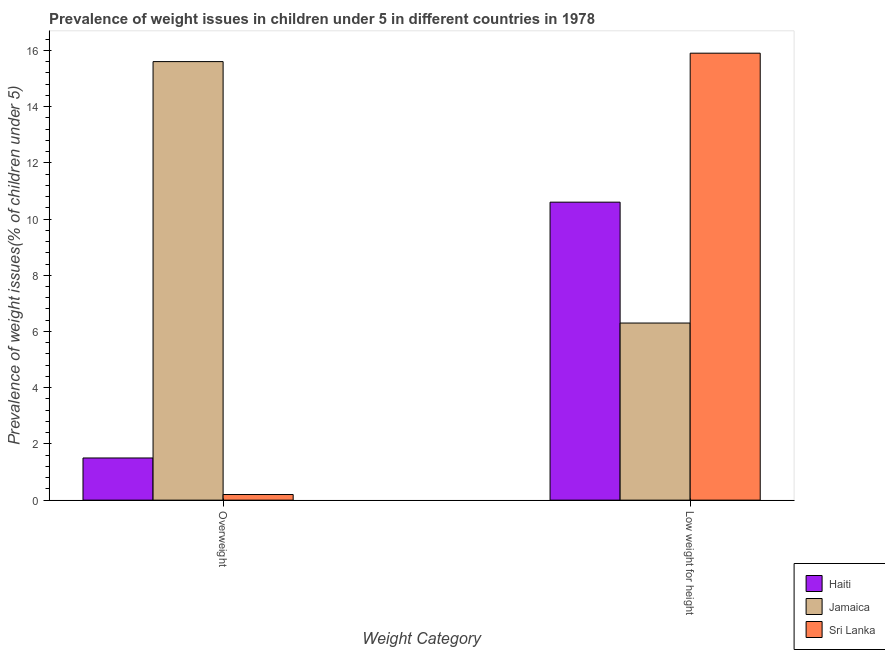Are the number of bars per tick equal to the number of legend labels?
Make the answer very short. Yes. How many bars are there on the 1st tick from the left?
Offer a terse response. 3. What is the label of the 1st group of bars from the left?
Give a very brief answer. Overweight. What is the percentage of underweight children in Haiti?
Provide a short and direct response. 10.6. Across all countries, what is the maximum percentage of overweight children?
Your response must be concise. 15.6. Across all countries, what is the minimum percentage of underweight children?
Your response must be concise. 6.3. In which country was the percentage of underweight children maximum?
Your answer should be very brief. Sri Lanka. In which country was the percentage of overweight children minimum?
Make the answer very short. Sri Lanka. What is the total percentage of underweight children in the graph?
Your response must be concise. 32.8. What is the difference between the percentage of overweight children in Sri Lanka and that in Jamaica?
Your answer should be compact. -15.4. What is the difference between the percentage of overweight children in Jamaica and the percentage of underweight children in Haiti?
Give a very brief answer. 5. What is the average percentage of overweight children per country?
Keep it short and to the point. 5.77. What is the difference between the percentage of underweight children and percentage of overweight children in Jamaica?
Give a very brief answer. -9.3. What is the ratio of the percentage of underweight children in Sri Lanka to that in Jamaica?
Your answer should be very brief. 2.52. What does the 2nd bar from the left in Overweight represents?
Offer a terse response. Jamaica. What does the 1st bar from the right in Low weight for height represents?
Offer a very short reply. Sri Lanka. Are all the bars in the graph horizontal?
Your answer should be compact. No. How many countries are there in the graph?
Keep it short and to the point. 3. What is the difference between two consecutive major ticks on the Y-axis?
Make the answer very short. 2. Are the values on the major ticks of Y-axis written in scientific E-notation?
Make the answer very short. No. Does the graph contain any zero values?
Provide a short and direct response. No. What is the title of the graph?
Offer a terse response. Prevalence of weight issues in children under 5 in different countries in 1978. What is the label or title of the X-axis?
Your answer should be compact. Weight Category. What is the label or title of the Y-axis?
Keep it short and to the point. Prevalence of weight issues(% of children under 5). What is the Prevalence of weight issues(% of children under 5) in Haiti in Overweight?
Your response must be concise. 1.5. What is the Prevalence of weight issues(% of children under 5) in Jamaica in Overweight?
Give a very brief answer. 15.6. What is the Prevalence of weight issues(% of children under 5) in Sri Lanka in Overweight?
Provide a succinct answer. 0.2. What is the Prevalence of weight issues(% of children under 5) in Haiti in Low weight for height?
Provide a succinct answer. 10.6. What is the Prevalence of weight issues(% of children under 5) of Jamaica in Low weight for height?
Ensure brevity in your answer.  6.3. What is the Prevalence of weight issues(% of children under 5) in Sri Lanka in Low weight for height?
Your answer should be very brief. 15.9. Across all Weight Category, what is the maximum Prevalence of weight issues(% of children under 5) in Haiti?
Provide a succinct answer. 10.6. Across all Weight Category, what is the maximum Prevalence of weight issues(% of children under 5) of Jamaica?
Offer a very short reply. 15.6. Across all Weight Category, what is the maximum Prevalence of weight issues(% of children under 5) in Sri Lanka?
Offer a very short reply. 15.9. Across all Weight Category, what is the minimum Prevalence of weight issues(% of children under 5) in Haiti?
Offer a very short reply. 1.5. Across all Weight Category, what is the minimum Prevalence of weight issues(% of children under 5) of Jamaica?
Offer a very short reply. 6.3. Across all Weight Category, what is the minimum Prevalence of weight issues(% of children under 5) of Sri Lanka?
Provide a succinct answer. 0.2. What is the total Prevalence of weight issues(% of children under 5) of Haiti in the graph?
Your response must be concise. 12.1. What is the total Prevalence of weight issues(% of children under 5) in Jamaica in the graph?
Make the answer very short. 21.9. What is the difference between the Prevalence of weight issues(% of children under 5) in Sri Lanka in Overweight and that in Low weight for height?
Provide a short and direct response. -15.7. What is the difference between the Prevalence of weight issues(% of children under 5) of Haiti in Overweight and the Prevalence of weight issues(% of children under 5) of Sri Lanka in Low weight for height?
Make the answer very short. -14.4. What is the difference between the Prevalence of weight issues(% of children under 5) of Jamaica in Overweight and the Prevalence of weight issues(% of children under 5) of Sri Lanka in Low weight for height?
Make the answer very short. -0.3. What is the average Prevalence of weight issues(% of children under 5) of Haiti per Weight Category?
Offer a terse response. 6.05. What is the average Prevalence of weight issues(% of children under 5) in Jamaica per Weight Category?
Make the answer very short. 10.95. What is the average Prevalence of weight issues(% of children under 5) of Sri Lanka per Weight Category?
Your answer should be very brief. 8.05. What is the difference between the Prevalence of weight issues(% of children under 5) of Haiti and Prevalence of weight issues(% of children under 5) of Jamaica in Overweight?
Make the answer very short. -14.1. What is the difference between the Prevalence of weight issues(% of children under 5) of Haiti and Prevalence of weight issues(% of children under 5) of Jamaica in Low weight for height?
Keep it short and to the point. 4.3. What is the difference between the Prevalence of weight issues(% of children under 5) of Jamaica and Prevalence of weight issues(% of children under 5) of Sri Lanka in Low weight for height?
Make the answer very short. -9.6. What is the ratio of the Prevalence of weight issues(% of children under 5) in Haiti in Overweight to that in Low weight for height?
Your answer should be compact. 0.14. What is the ratio of the Prevalence of weight issues(% of children under 5) in Jamaica in Overweight to that in Low weight for height?
Offer a very short reply. 2.48. What is the ratio of the Prevalence of weight issues(% of children under 5) in Sri Lanka in Overweight to that in Low weight for height?
Your answer should be very brief. 0.01. What is the difference between the highest and the second highest Prevalence of weight issues(% of children under 5) in Haiti?
Offer a very short reply. 9.1. What is the difference between the highest and the second highest Prevalence of weight issues(% of children under 5) of Jamaica?
Provide a short and direct response. 9.3. What is the difference between the highest and the second highest Prevalence of weight issues(% of children under 5) in Sri Lanka?
Ensure brevity in your answer.  15.7. What is the difference between the highest and the lowest Prevalence of weight issues(% of children under 5) of Jamaica?
Offer a terse response. 9.3. 